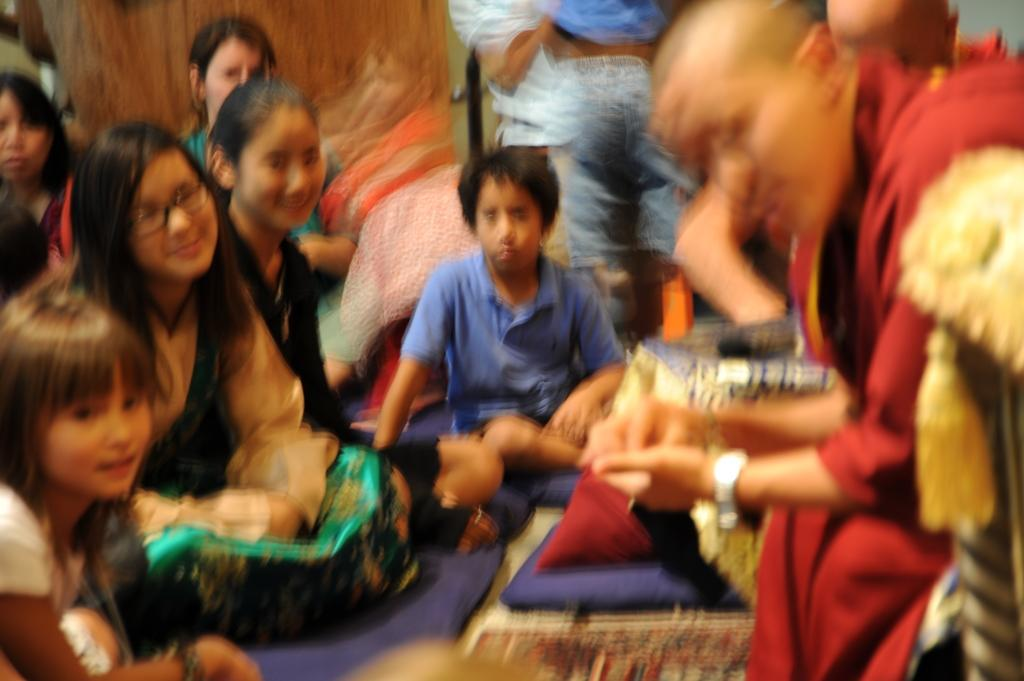What are the people in the image doing? There are people sitting and standing in the image. Where are the people located in the image? The people are on the floor. What type of patch is being used to measure the distance between the people in the image? There is no patch or measuring device present in the image; the people are simply sitting and standing on the floor. 